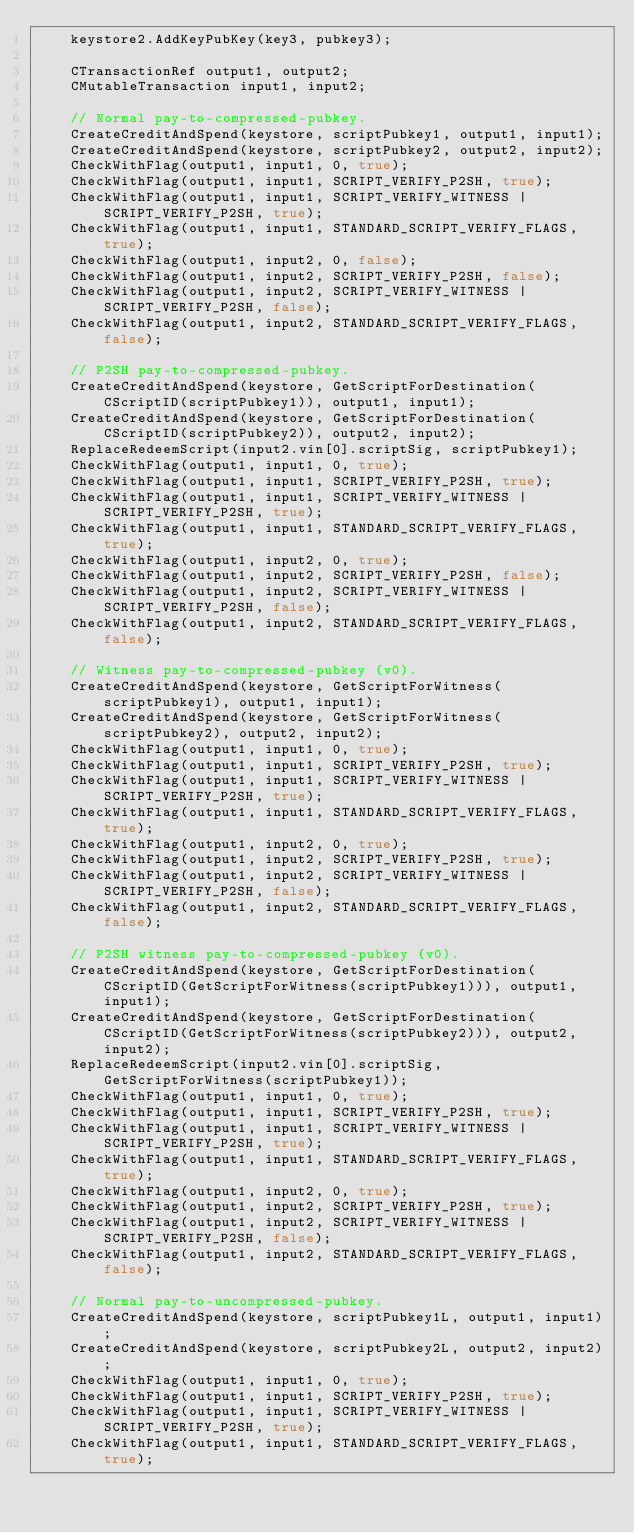Convert code to text. <code><loc_0><loc_0><loc_500><loc_500><_C++_>    keystore2.AddKeyPubKey(key3, pubkey3);

    CTransactionRef output1, output2;
    CMutableTransaction input1, input2;

    // Normal pay-to-compressed-pubkey.
    CreateCreditAndSpend(keystore, scriptPubkey1, output1, input1);
    CreateCreditAndSpend(keystore, scriptPubkey2, output2, input2);
    CheckWithFlag(output1, input1, 0, true);
    CheckWithFlag(output1, input1, SCRIPT_VERIFY_P2SH, true);
    CheckWithFlag(output1, input1, SCRIPT_VERIFY_WITNESS | SCRIPT_VERIFY_P2SH, true);
    CheckWithFlag(output1, input1, STANDARD_SCRIPT_VERIFY_FLAGS, true);
    CheckWithFlag(output1, input2, 0, false);
    CheckWithFlag(output1, input2, SCRIPT_VERIFY_P2SH, false);
    CheckWithFlag(output1, input2, SCRIPT_VERIFY_WITNESS | SCRIPT_VERIFY_P2SH, false);
    CheckWithFlag(output1, input2, STANDARD_SCRIPT_VERIFY_FLAGS, false);

    // P2SH pay-to-compressed-pubkey.
    CreateCreditAndSpend(keystore, GetScriptForDestination(CScriptID(scriptPubkey1)), output1, input1);
    CreateCreditAndSpend(keystore, GetScriptForDestination(CScriptID(scriptPubkey2)), output2, input2);
    ReplaceRedeemScript(input2.vin[0].scriptSig, scriptPubkey1);
    CheckWithFlag(output1, input1, 0, true);
    CheckWithFlag(output1, input1, SCRIPT_VERIFY_P2SH, true);
    CheckWithFlag(output1, input1, SCRIPT_VERIFY_WITNESS | SCRIPT_VERIFY_P2SH, true);
    CheckWithFlag(output1, input1, STANDARD_SCRIPT_VERIFY_FLAGS, true);
    CheckWithFlag(output1, input2, 0, true);
    CheckWithFlag(output1, input2, SCRIPT_VERIFY_P2SH, false);
    CheckWithFlag(output1, input2, SCRIPT_VERIFY_WITNESS | SCRIPT_VERIFY_P2SH, false);
    CheckWithFlag(output1, input2, STANDARD_SCRIPT_VERIFY_FLAGS, false);

    // Witness pay-to-compressed-pubkey (v0).
    CreateCreditAndSpend(keystore, GetScriptForWitness(scriptPubkey1), output1, input1);
    CreateCreditAndSpend(keystore, GetScriptForWitness(scriptPubkey2), output2, input2);
    CheckWithFlag(output1, input1, 0, true);
    CheckWithFlag(output1, input1, SCRIPT_VERIFY_P2SH, true);
    CheckWithFlag(output1, input1, SCRIPT_VERIFY_WITNESS | SCRIPT_VERIFY_P2SH, true);
    CheckWithFlag(output1, input1, STANDARD_SCRIPT_VERIFY_FLAGS, true);
    CheckWithFlag(output1, input2, 0, true);
    CheckWithFlag(output1, input2, SCRIPT_VERIFY_P2SH, true);
    CheckWithFlag(output1, input2, SCRIPT_VERIFY_WITNESS | SCRIPT_VERIFY_P2SH, false);
    CheckWithFlag(output1, input2, STANDARD_SCRIPT_VERIFY_FLAGS, false);

    // P2SH witness pay-to-compressed-pubkey (v0).
    CreateCreditAndSpend(keystore, GetScriptForDestination(CScriptID(GetScriptForWitness(scriptPubkey1))), output1, input1);
    CreateCreditAndSpend(keystore, GetScriptForDestination(CScriptID(GetScriptForWitness(scriptPubkey2))), output2, input2);
    ReplaceRedeemScript(input2.vin[0].scriptSig, GetScriptForWitness(scriptPubkey1));
    CheckWithFlag(output1, input1, 0, true);
    CheckWithFlag(output1, input1, SCRIPT_VERIFY_P2SH, true);
    CheckWithFlag(output1, input1, SCRIPT_VERIFY_WITNESS | SCRIPT_VERIFY_P2SH, true);
    CheckWithFlag(output1, input1, STANDARD_SCRIPT_VERIFY_FLAGS, true);
    CheckWithFlag(output1, input2, 0, true);
    CheckWithFlag(output1, input2, SCRIPT_VERIFY_P2SH, true);
    CheckWithFlag(output1, input2, SCRIPT_VERIFY_WITNESS | SCRIPT_VERIFY_P2SH, false);
    CheckWithFlag(output1, input2, STANDARD_SCRIPT_VERIFY_FLAGS, false);

    // Normal pay-to-uncompressed-pubkey.
    CreateCreditAndSpend(keystore, scriptPubkey1L, output1, input1);
    CreateCreditAndSpend(keystore, scriptPubkey2L, output2, input2);
    CheckWithFlag(output1, input1, 0, true);
    CheckWithFlag(output1, input1, SCRIPT_VERIFY_P2SH, true);
    CheckWithFlag(output1, input1, SCRIPT_VERIFY_WITNESS | SCRIPT_VERIFY_P2SH, true);
    CheckWithFlag(output1, input1, STANDARD_SCRIPT_VERIFY_FLAGS, true);</code> 